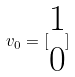Convert formula to latex. <formula><loc_0><loc_0><loc_500><loc_500>v _ { 0 } = [ \begin{matrix} 1 \\ 0 \end{matrix} ]</formula> 